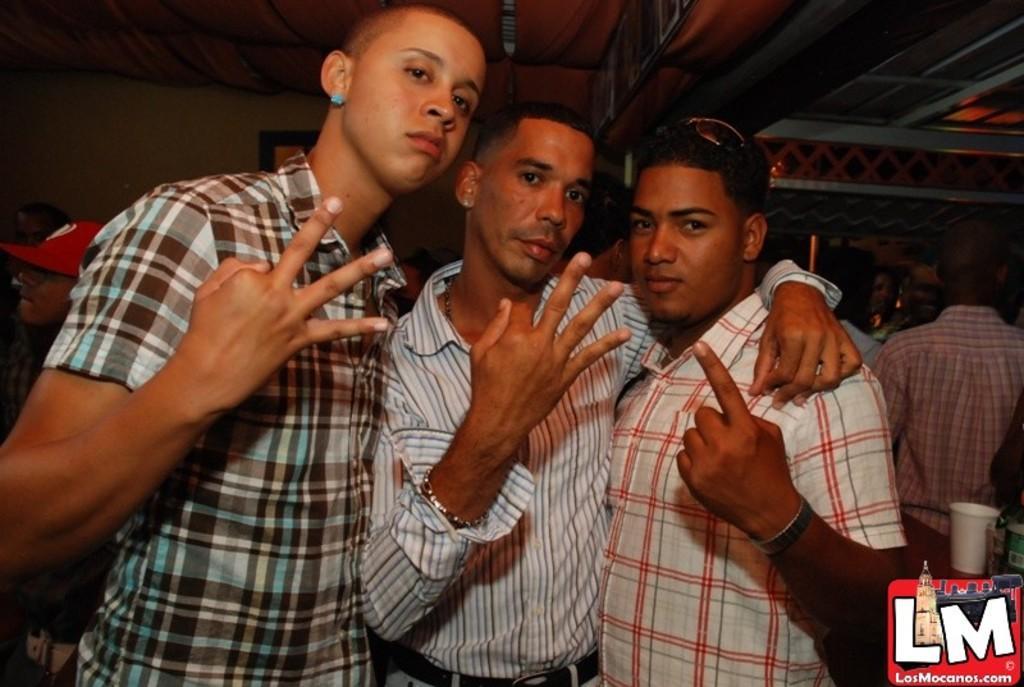Describe this image in one or two sentences. In front of the picture, we see three men are standing. They are posing for the photo. Behind them, we see the people are standing. On the right side, we see the people are standing. Beside them, we see a table on which a water bottle and a glass are placed. In the background, we see a wall on which a photo frame is placed. At the top, we see the roof of the building. 